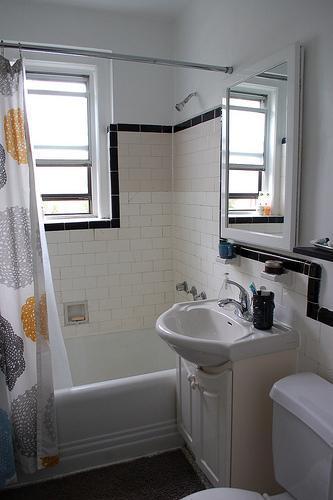How many toilets are there?
Give a very brief answer. 1. 